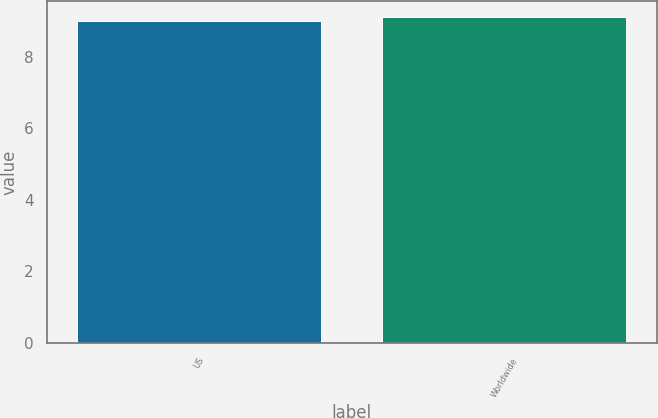<chart> <loc_0><loc_0><loc_500><loc_500><bar_chart><fcel>US<fcel>Worldwide<nl><fcel>9<fcel>9.1<nl></chart> 